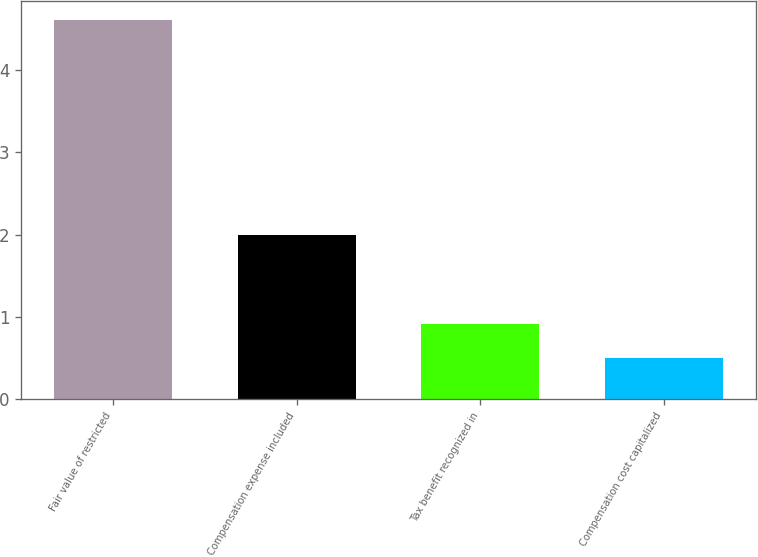Convert chart to OTSL. <chart><loc_0><loc_0><loc_500><loc_500><bar_chart><fcel>Fair value of restricted<fcel>Compensation expense included<fcel>Tax benefit recognized in<fcel>Compensation cost capitalized<nl><fcel>4.6<fcel>2<fcel>0.91<fcel>0.5<nl></chart> 